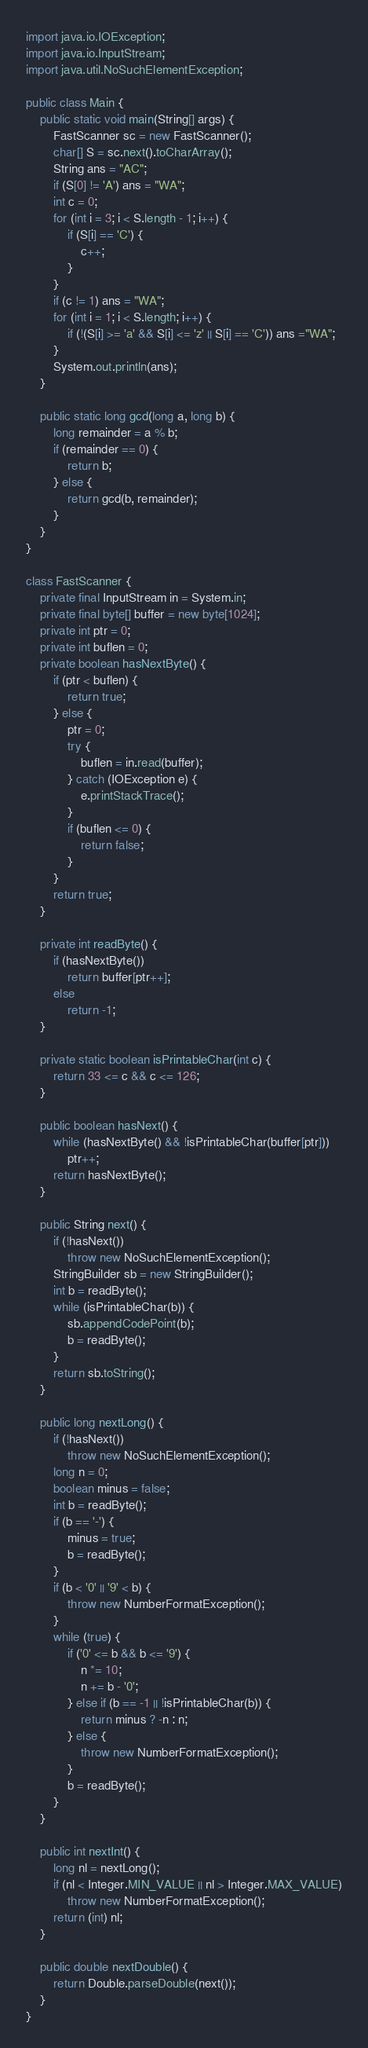Convert code to text. <code><loc_0><loc_0><loc_500><loc_500><_Java_>import java.io.IOException;
import java.io.InputStream;
import java.util.NoSuchElementException;

public class Main {
	public static void main(String[] args) {
		FastScanner sc = new FastScanner();
		char[] S = sc.next().toCharArray();
		String ans = "AC";
		if (S[0] != 'A') ans = "WA";
		int c = 0;
		for (int i = 3; i < S.length - 1; i++) {
			if (S[i] == 'C') {
				c++;
			}
		}
		if (c != 1) ans = "WA";
		for (int i = 1; i < S.length; i++) {
			if (!(S[i] >= 'a' && S[i] <= 'z' || S[i] == 'C')) ans ="WA";
		}
		System.out.println(ans);
	}

	public static long gcd(long a, long b) {
		long remainder = a % b;
		if (remainder == 0) {
			return b;
		} else {
			return gcd(b, remainder);
		}
	}
}

class FastScanner {
    private final InputStream in = System.in;
    private final byte[] buffer = new byte[1024];
    private int ptr = 0;
    private int buflen = 0;
    private boolean hasNextByte() {
        if (ptr < buflen) {
            return true;
        } else {
            ptr = 0;
            try {
                buflen = in.read(buffer);
            } catch (IOException e) {
                e.printStackTrace();
            }
            if (buflen <= 0) {
                return false;
            }
        }
        return true;
    }

    private int readByte() {
        if (hasNextByte())
            return buffer[ptr++];
        else
            return -1;
    }

    private static boolean isPrintableChar(int c) {
        return 33 <= c && c <= 126;
    }

    public boolean hasNext() {
        while (hasNextByte() && !isPrintableChar(buffer[ptr]))
            ptr++;
        return hasNextByte();
    }

    public String next() {
        if (!hasNext())
            throw new NoSuchElementException();
        StringBuilder sb = new StringBuilder();
        int b = readByte();
        while (isPrintableChar(b)) {
            sb.appendCodePoint(b);
            b = readByte();
        }
        return sb.toString();
    }

    public long nextLong() {
        if (!hasNext())
            throw new NoSuchElementException();
        long n = 0;
        boolean minus = false;
        int b = readByte();
        if (b == '-') {
            minus = true;
            b = readByte();
        }
        if (b < '0' || '9' < b) {
            throw new NumberFormatException();
        }
        while (true) {
            if ('0' <= b && b <= '9') {
                n *= 10;
                n += b - '0';
            } else if (b == -1 || !isPrintableChar(b)) {
                return minus ? -n : n;
            } else {
                throw new NumberFormatException();
            }
            b = readByte();
        }
    }

    public int nextInt() {
        long nl = nextLong();
        if (nl < Integer.MIN_VALUE || nl > Integer.MAX_VALUE)
            throw new NumberFormatException();
        return (int) nl;
    }

    public double nextDouble() {
        return Double.parseDouble(next());
    }
}
</code> 